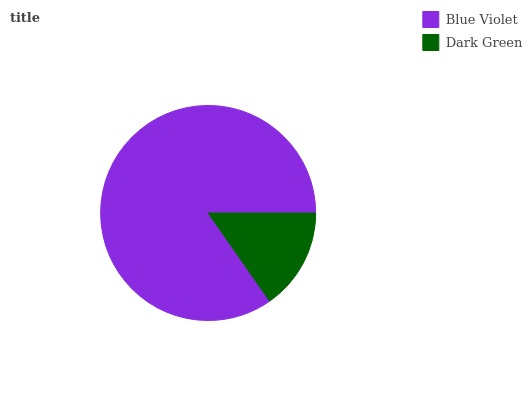Is Dark Green the minimum?
Answer yes or no. Yes. Is Blue Violet the maximum?
Answer yes or no. Yes. Is Dark Green the maximum?
Answer yes or no. No. Is Blue Violet greater than Dark Green?
Answer yes or no. Yes. Is Dark Green less than Blue Violet?
Answer yes or no. Yes. Is Dark Green greater than Blue Violet?
Answer yes or no. No. Is Blue Violet less than Dark Green?
Answer yes or no. No. Is Blue Violet the high median?
Answer yes or no. Yes. Is Dark Green the low median?
Answer yes or no. Yes. Is Dark Green the high median?
Answer yes or no. No. Is Blue Violet the low median?
Answer yes or no. No. 